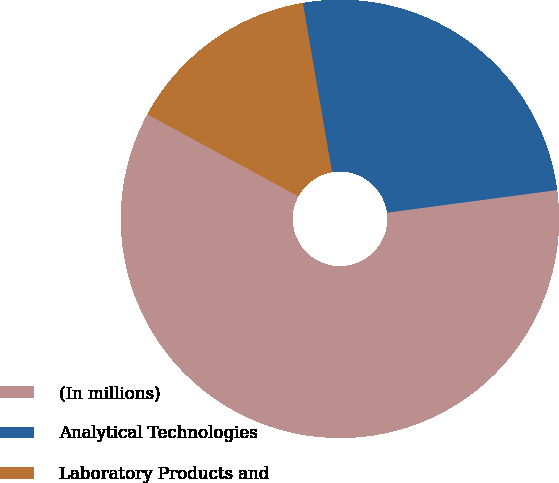Convert chart. <chart><loc_0><loc_0><loc_500><loc_500><pie_chart><fcel>(In millions)<fcel>Analytical Technologies<fcel>Laboratory Products and<nl><fcel>60.03%<fcel>25.61%<fcel>14.37%<nl></chart> 